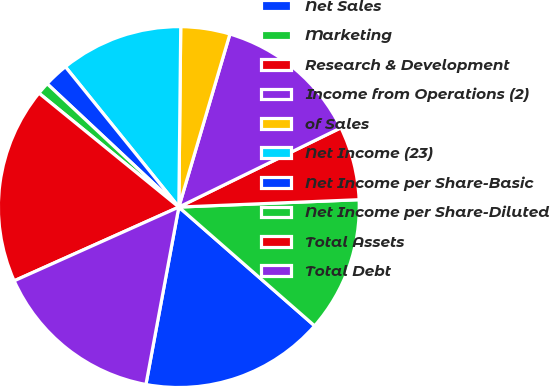Convert chart. <chart><loc_0><loc_0><loc_500><loc_500><pie_chart><fcel>Net Sales<fcel>Marketing<fcel>Research & Development<fcel>Income from Operations (2)<fcel>of Sales<fcel>Net Income (23)<fcel>Net Income per Share-Basic<fcel>Net Income per Share-Diluted<fcel>Total Assets<fcel>Total Debt<nl><fcel>16.48%<fcel>12.09%<fcel>6.59%<fcel>13.19%<fcel>4.4%<fcel>10.99%<fcel>2.2%<fcel>1.1%<fcel>17.58%<fcel>15.38%<nl></chart> 